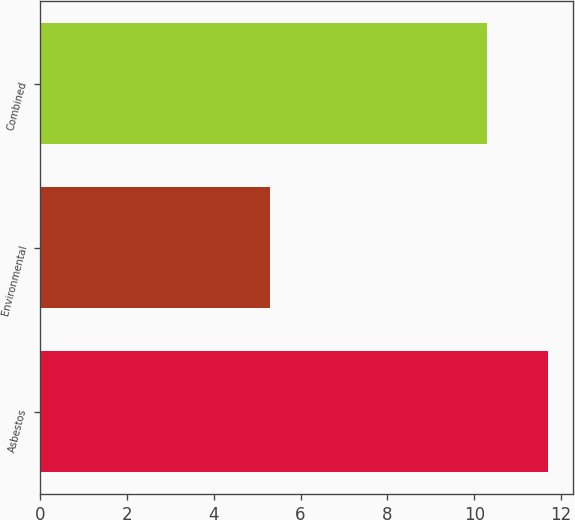Convert chart to OTSL. <chart><loc_0><loc_0><loc_500><loc_500><bar_chart><fcel>Asbestos<fcel>Environmental<fcel>Combined<nl><fcel>11.7<fcel>5.3<fcel>10.3<nl></chart> 